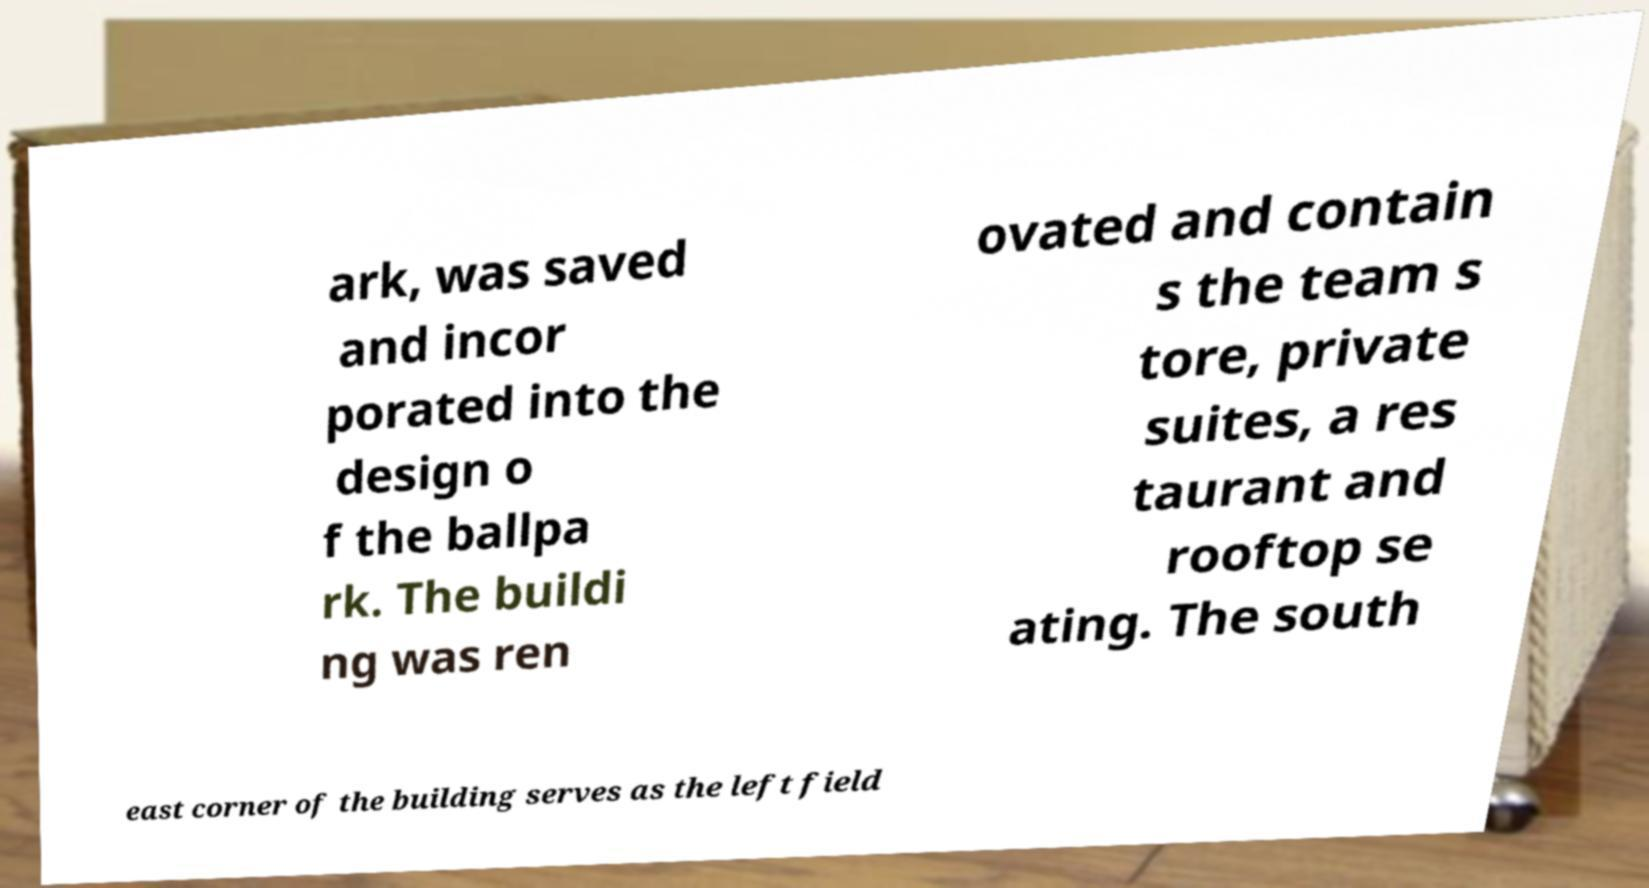For documentation purposes, I need the text within this image transcribed. Could you provide that? ark, was saved and incor porated into the design o f the ballpa rk. The buildi ng was ren ovated and contain s the team s tore, private suites, a res taurant and rooftop se ating. The south east corner of the building serves as the left field 